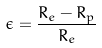<formula> <loc_0><loc_0><loc_500><loc_500>\epsilon = \frac { R _ { e } - R _ { p } } { R _ { e } }</formula> 